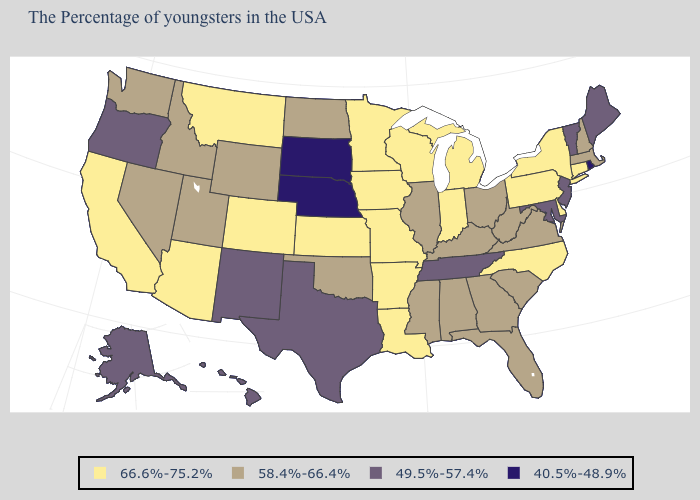What is the value of Washington?
Keep it brief. 58.4%-66.4%. Name the states that have a value in the range 40.5%-48.9%?
Concise answer only. Rhode Island, Nebraska, South Dakota. What is the value of Idaho?
Answer briefly. 58.4%-66.4%. Among the states that border Massachusetts , does Rhode Island have the highest value?
Give a very brief answer. No. Among the states that border New Hampshire , does Massachusetts have the lowest value?
Write a very short answer. No. Among the states that border Louisiana , does Texas have the lowest value?
Give a very brief answer. Yes. What is the value of Georgia?
Short answer required. 58.4%-66.4%. Does Alaska have the lowest value in the West?
Be succinct. Yes. Among the states that border Missouri , which have the highest value?
Answer briefly. Arkansas, Iowa, Kansas. What is the value of Kentucky?
Give a very brief answer. 58.4%-66.4%. What is the value of Missouri?
Answer briefly. 66.6%-75.2%. Name the states that have a value in the range 40.5%-48.9%?
Give a very brief answer. Rhode Island, Nebraska, South Dakota. Does North Dakota have the highest value in the USA?
Concise answer only. No. Among the states that border Georgia , which have the highest value?
Be succinct. North Carolina. Does Ohio have a higher value than Oklahoma?
Keep it brief. No. 